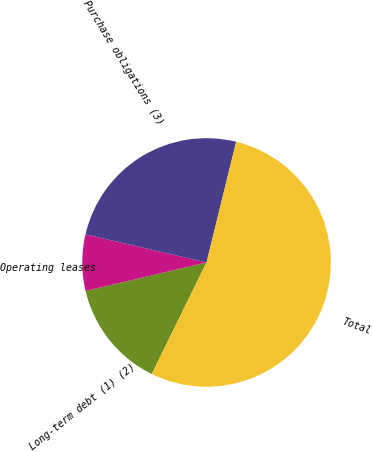<chart> <loc_0><loc_0><loc_500><loc_500><pie_chart><fcel>Long-term debt (1) (2)<fcel>Operating leases<fcel>Purchase obligations (3)<fcel>Total<nl><fcel>14.05%<fcel>7.32%<fcel>25.2%<fcel>53.44%<nl></chart> 